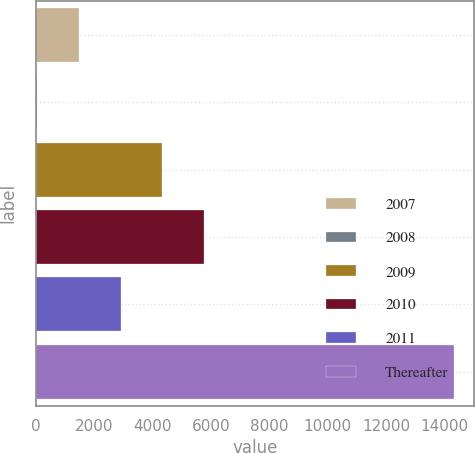<chart> <loc_0><loc_0><loc_500><loc_500><bar_chart><fcel>2007<fcel>2008<fcel>2009<fcel>2010<fcel>2011<fcel>Thereafter<nl><fcel>1475.7<fcel>50<fcel>4327.1<fcel>5752.8<fcel>2901.4<fcel>14307<nl></chart> 